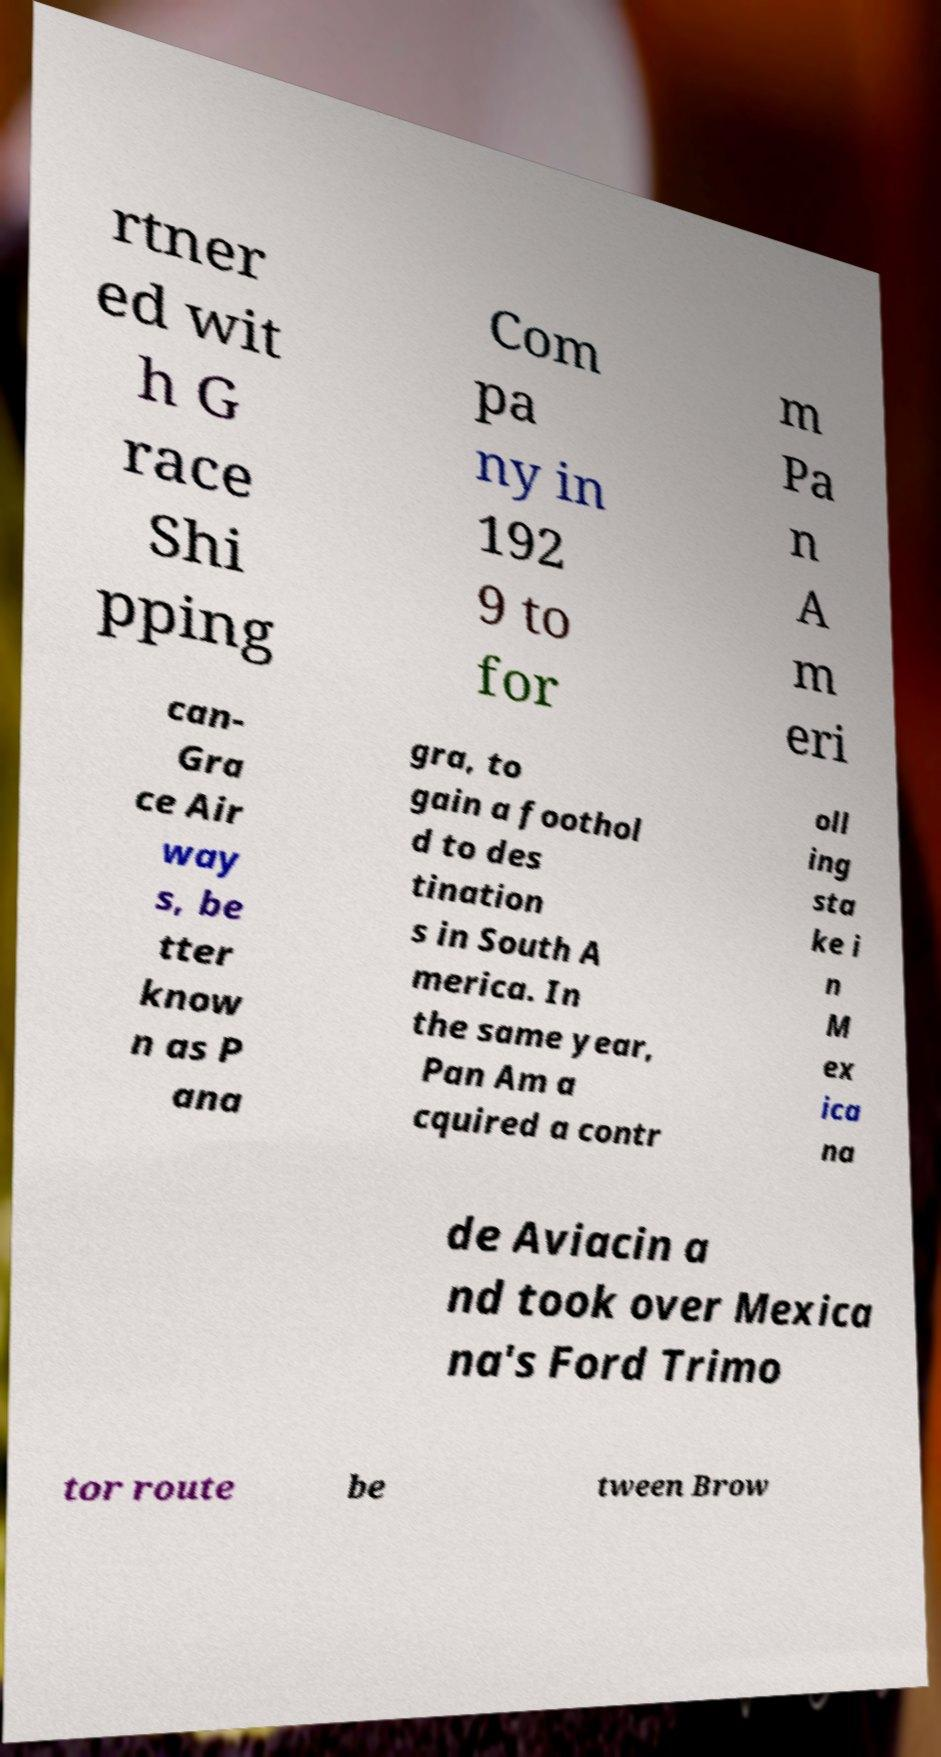Please identify and transcribe the text found in this image. rtner ed wit h G race Shi pping Com pa ny in 192 9 to for m Pa n A m eri can- Gra ce Air way s, be tter know n as P ana gra, to gain a foothol d to des tination s in South A merica. In the same year, Pan Am a cquired a contr oll ing sta ke i n M ex ica na de Aviacin a nd took over Mexica na's Ford Trimo tor route be tween Brow 